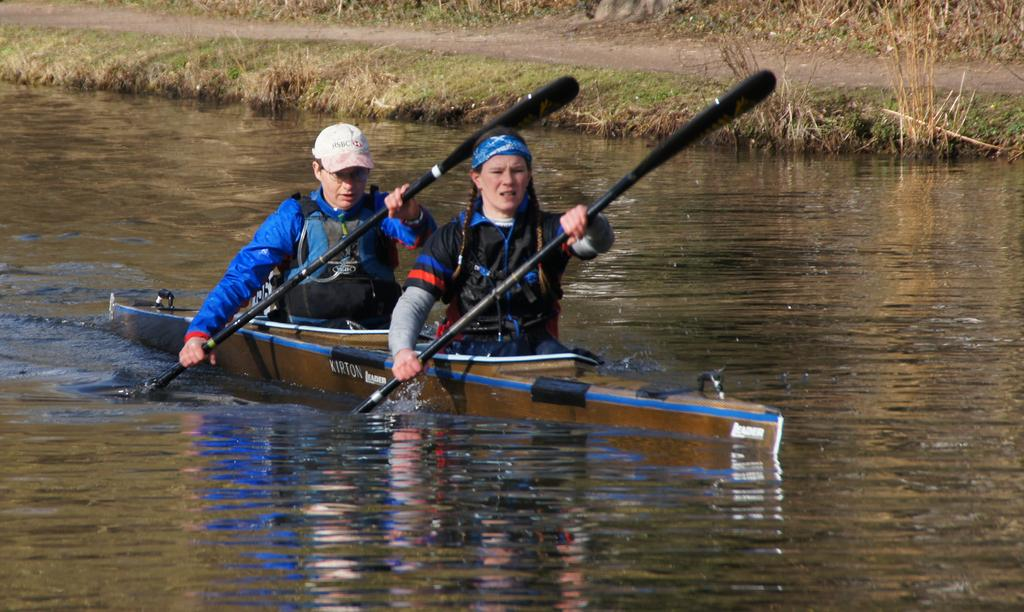What is the main subject in the center of the image? There is a boat in the center of the image. What are the people in the boat doing? The people are sitting in the boat and holding rows. What is at the bottom of the image? There is water at the bottom of the image. What can be seen in the background of the image? There is grass visible in the background. What is the condition of the people's faces in the image? There is no information about the condition of the people's faces in the image, as the focus is on the boat and the water. 